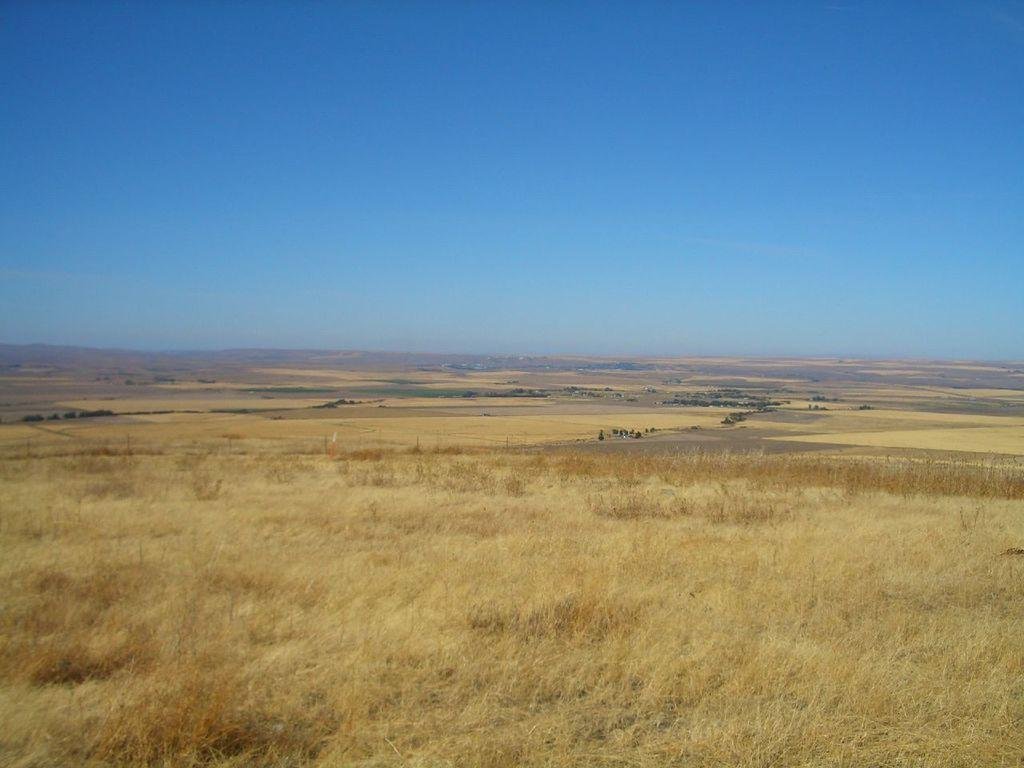What type of surface is visible on the ground in the image? The ground in the image is covered with grass. Can you describe the texture or appearance of the grass? The grass appears to be green and evenly spread across the ground. What might be the purpose of the grass in the image? The grass could be providing a natural and aesthetically pleasing surface for the area depicted in the image. How many jellyfish can be seen swimming in the grass in the image? There are no jellyfish present in the image, as the ground is covered with grass and not water. 